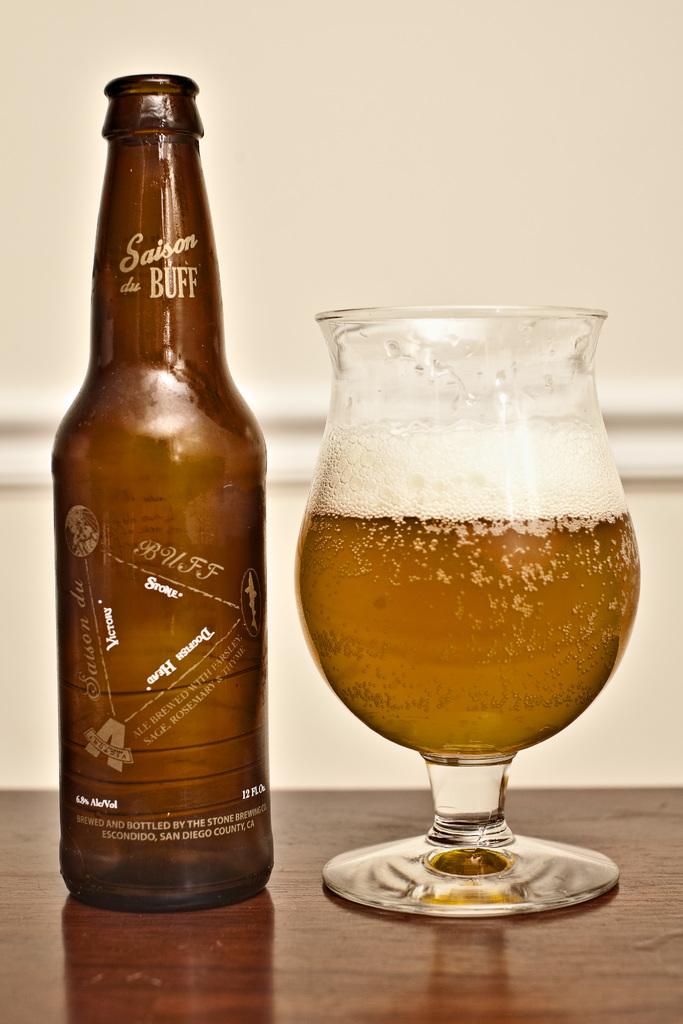What is the name of beer on the bottle?
Provide a succinct answer. Saison du buff. How many oz is the bottle?
Provide a short and direct response. 12. 